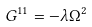<formula> <loc_0><loc_0><loc_500><loc_500>G ^ { 1 1 } = - \lambda \Omega ^ { 2 }</formula> 